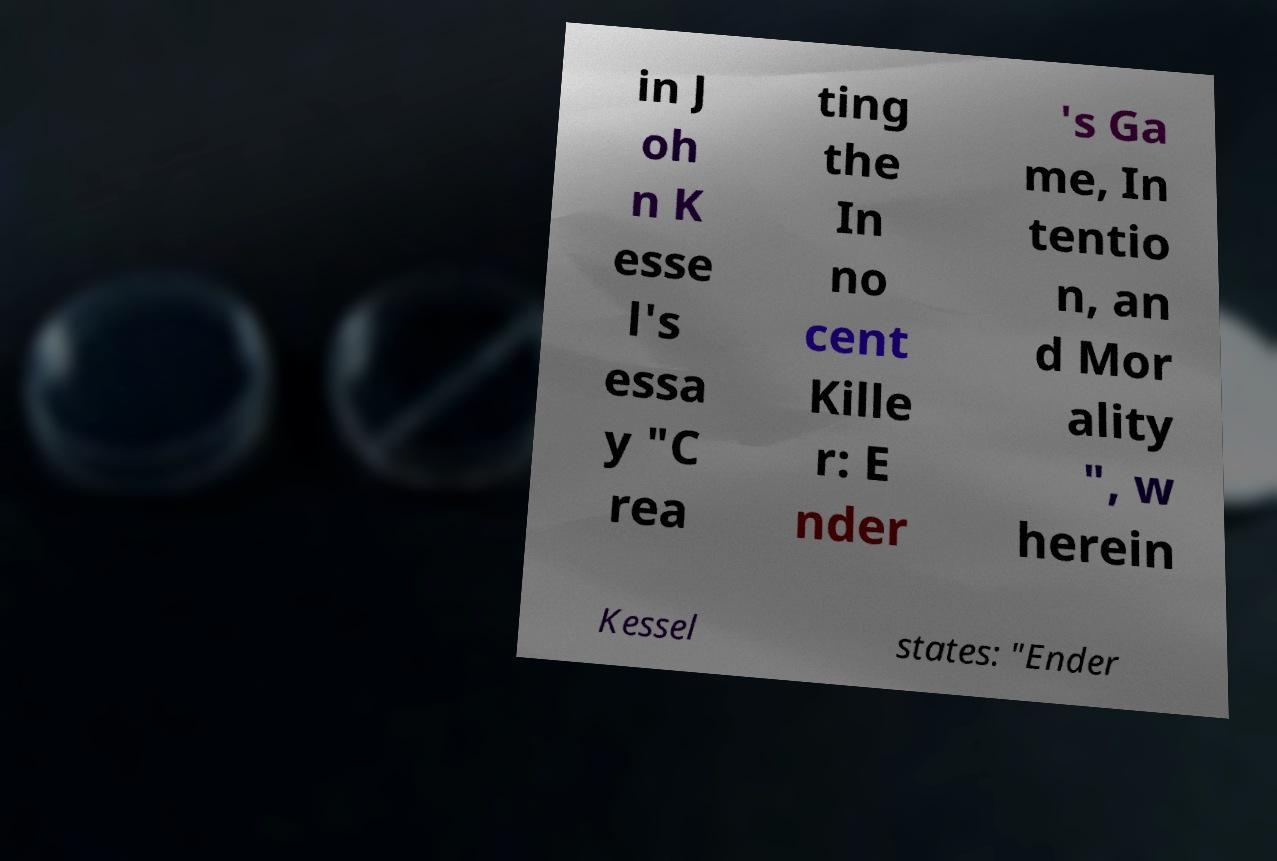Please read and relay the text visible in this image. What does it say? in J oh n K esse l's essa y "C rea ting the In no cent Kille r: E nder 's Ga me, In tentio n, an d Mor ality ", w herein Kessel states: "Ender 